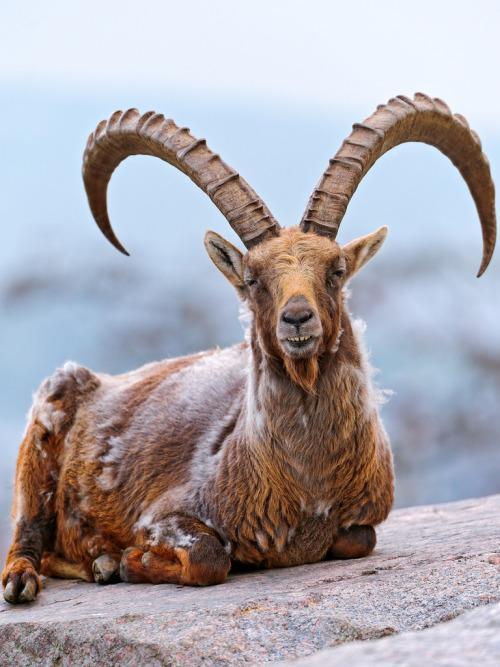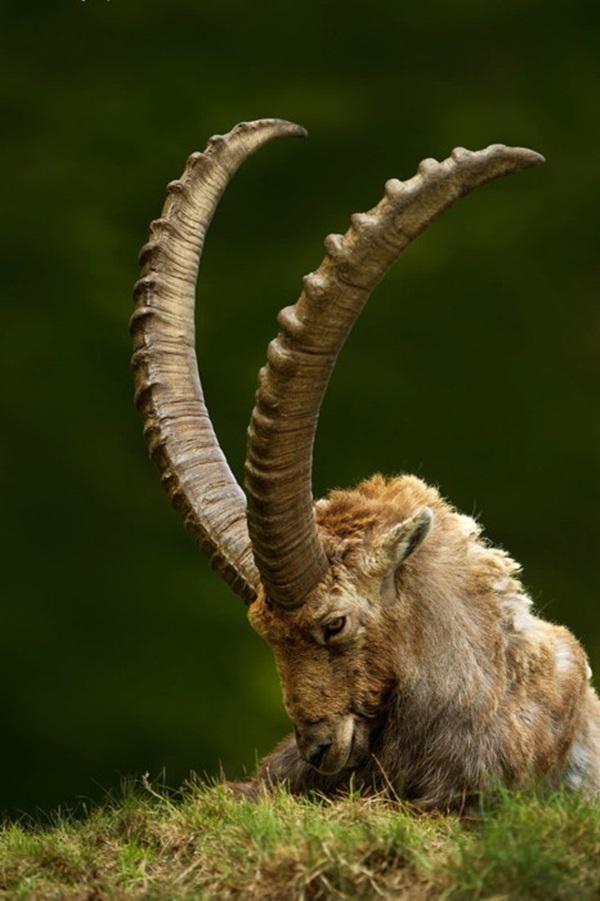The first image is the image on the left, the second image is the image on the right. For the images displayed, is the sentence "The animal in the image on the left is looking into the camera." factually correct? Answer yes or no. Yes. 